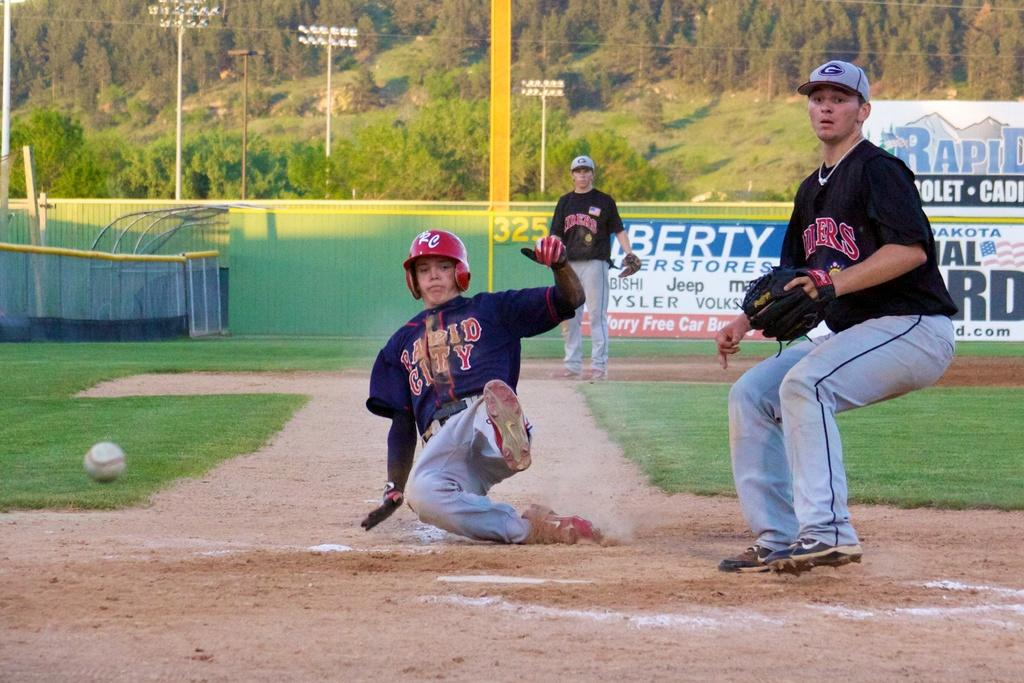<image>
Share a concise interpretation of the image provided. a person from Rapid City sliding to homeplate 